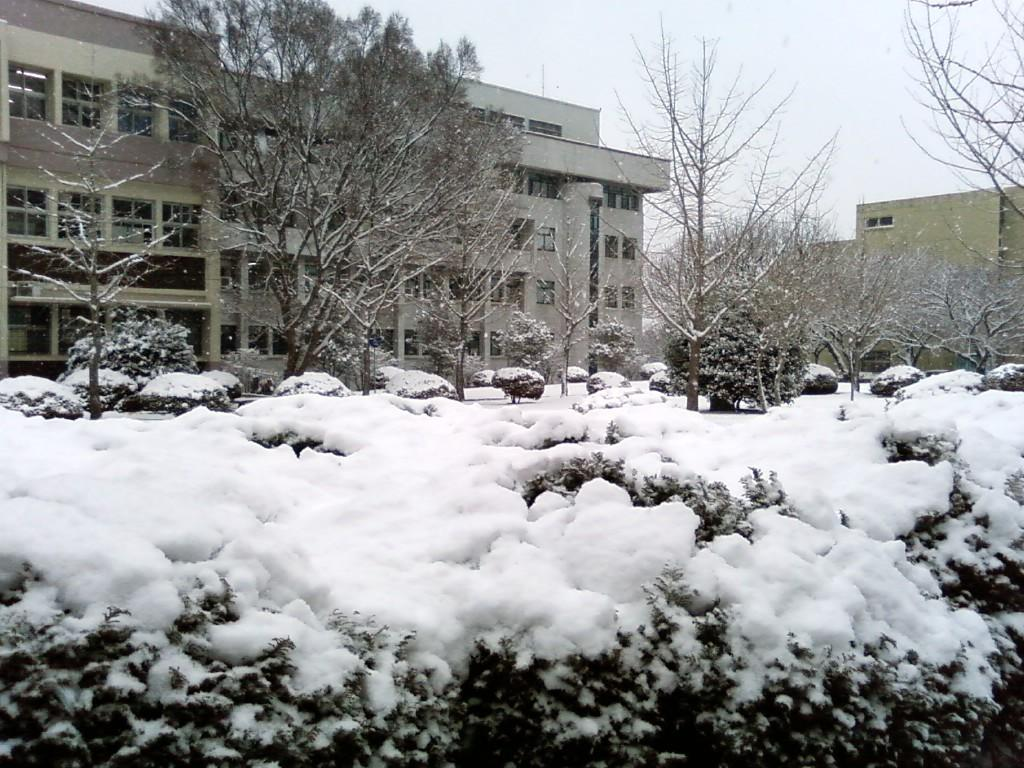What is located in the center of the image? There are buildings and trees in the center of the image. What is the condition of the ground in the image? There is snow at the bottom of the image. What can be seen in the background of the image? The sky is visible in the background of the image. What type of cloud can be seen driving a car in the image? There are no clouds or cars present in the image. How many houses are visible in the image? The image does not show any houses; it features buildings and trees. 